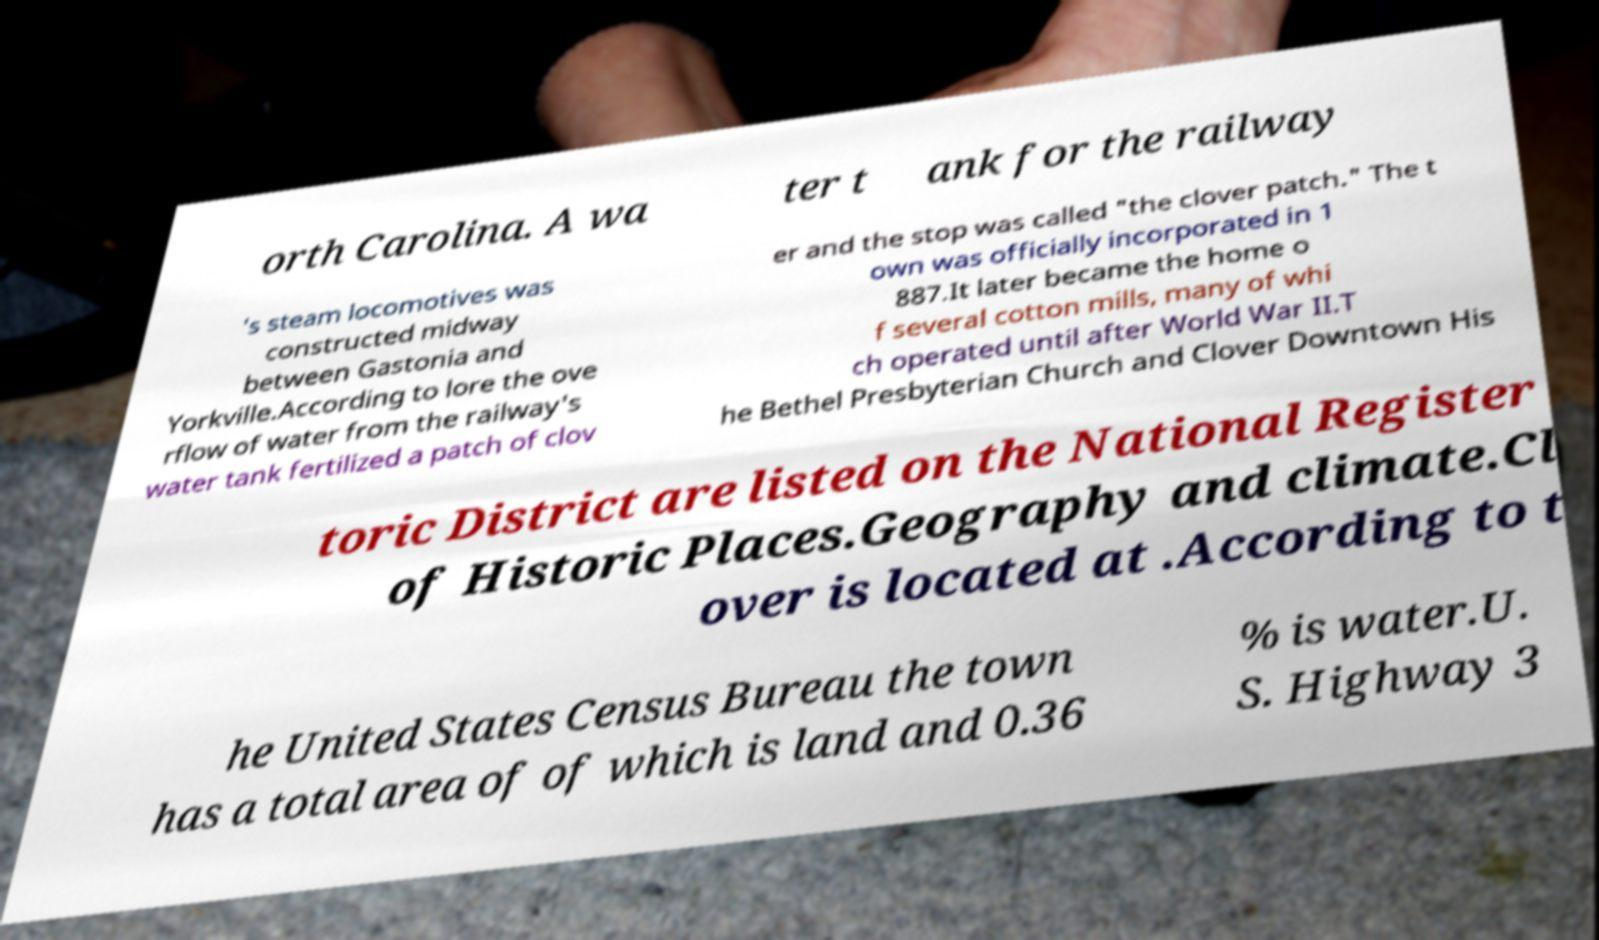Can you accurately transcribe the text from the provided image for me? orth Carolina. A wa ter t ank for the railway 's steam locomotives was constructed midway between Gastonia and Yorkville.According to lore the ove rflow of water from the railway's water tank fertilized a patch of clov er and the stop was called "the clover patch." The t own was officially incorporated in 1 887.It later became the home o f several cotton mills, many of whi ch operated until after World War II.T he Bethel Presbyterian Church and Clover Downtown His toric District are listed on the National Register of Historic Places.Geography and climate.Cl over is located at .According to t he United States Census Bureau the town has a total area of of which is land and 0.36 % is water.U. S. Highway 3 